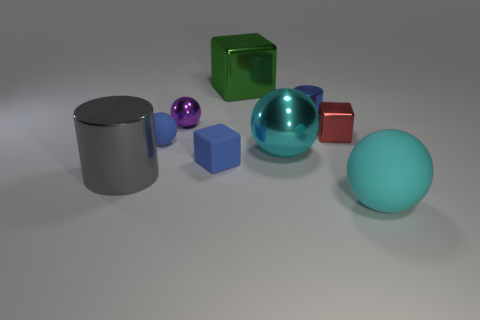Does the large ball behind the large matte object have the same color as the rubber sphere that is in front of the small matte ball? Yes, both the large ball positioned behind the large cylindrical matte object and the rubber sphere in front of the small matte ball exhibit a similar shade of teal, reflecting the light in a way that suggests they have the same color. 